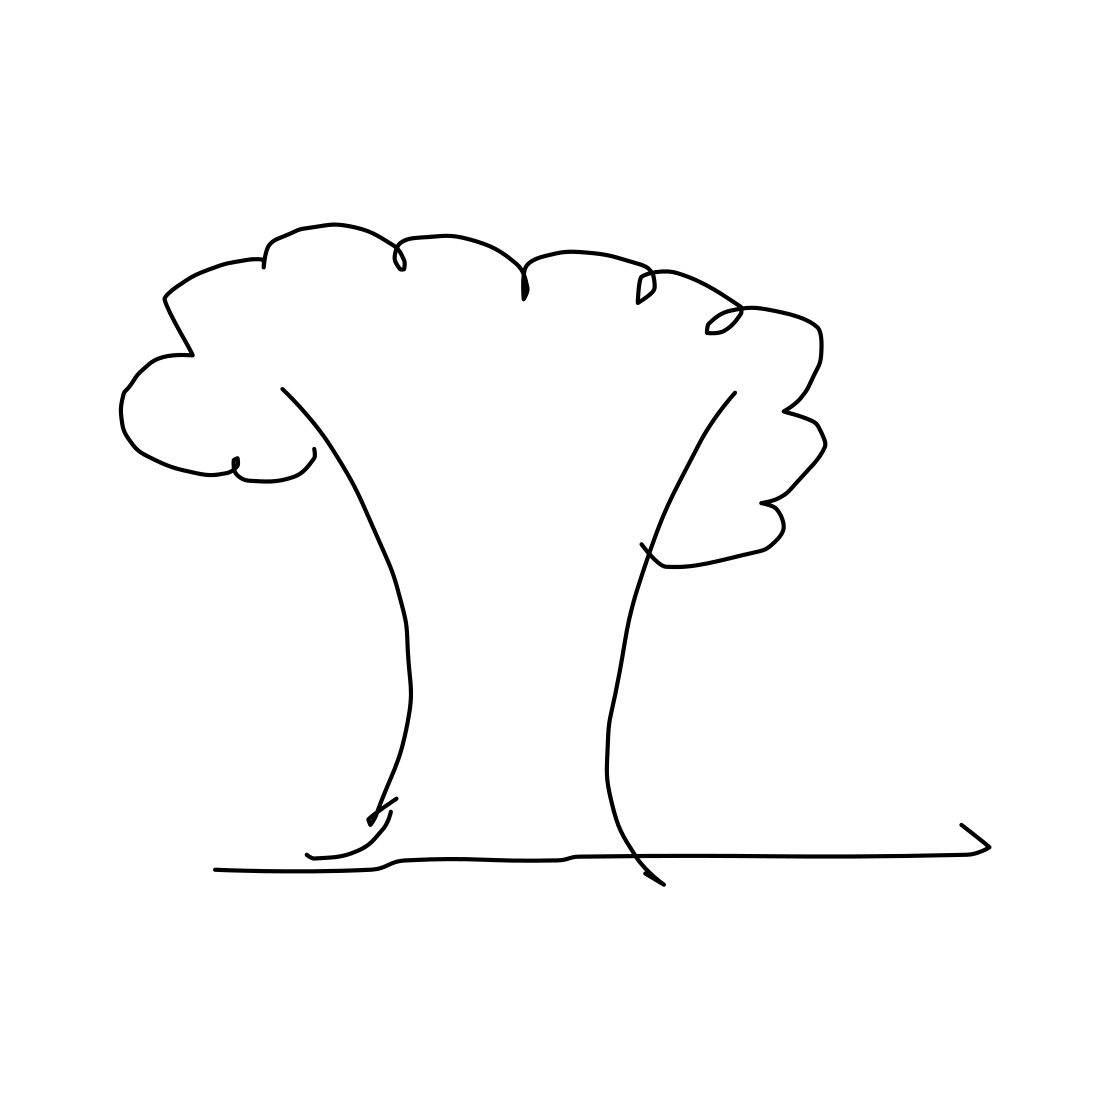Is this a tree in the image? Yes 